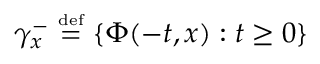<formula> <loc_0><loc_0><loc_500><loc_500>\gamma _ { x } ^ { - } \ { \overset { \underset { d e f } { = } } \ \{ \Phi ( - t , x ) \colon t \geq 0 \}</formula> 